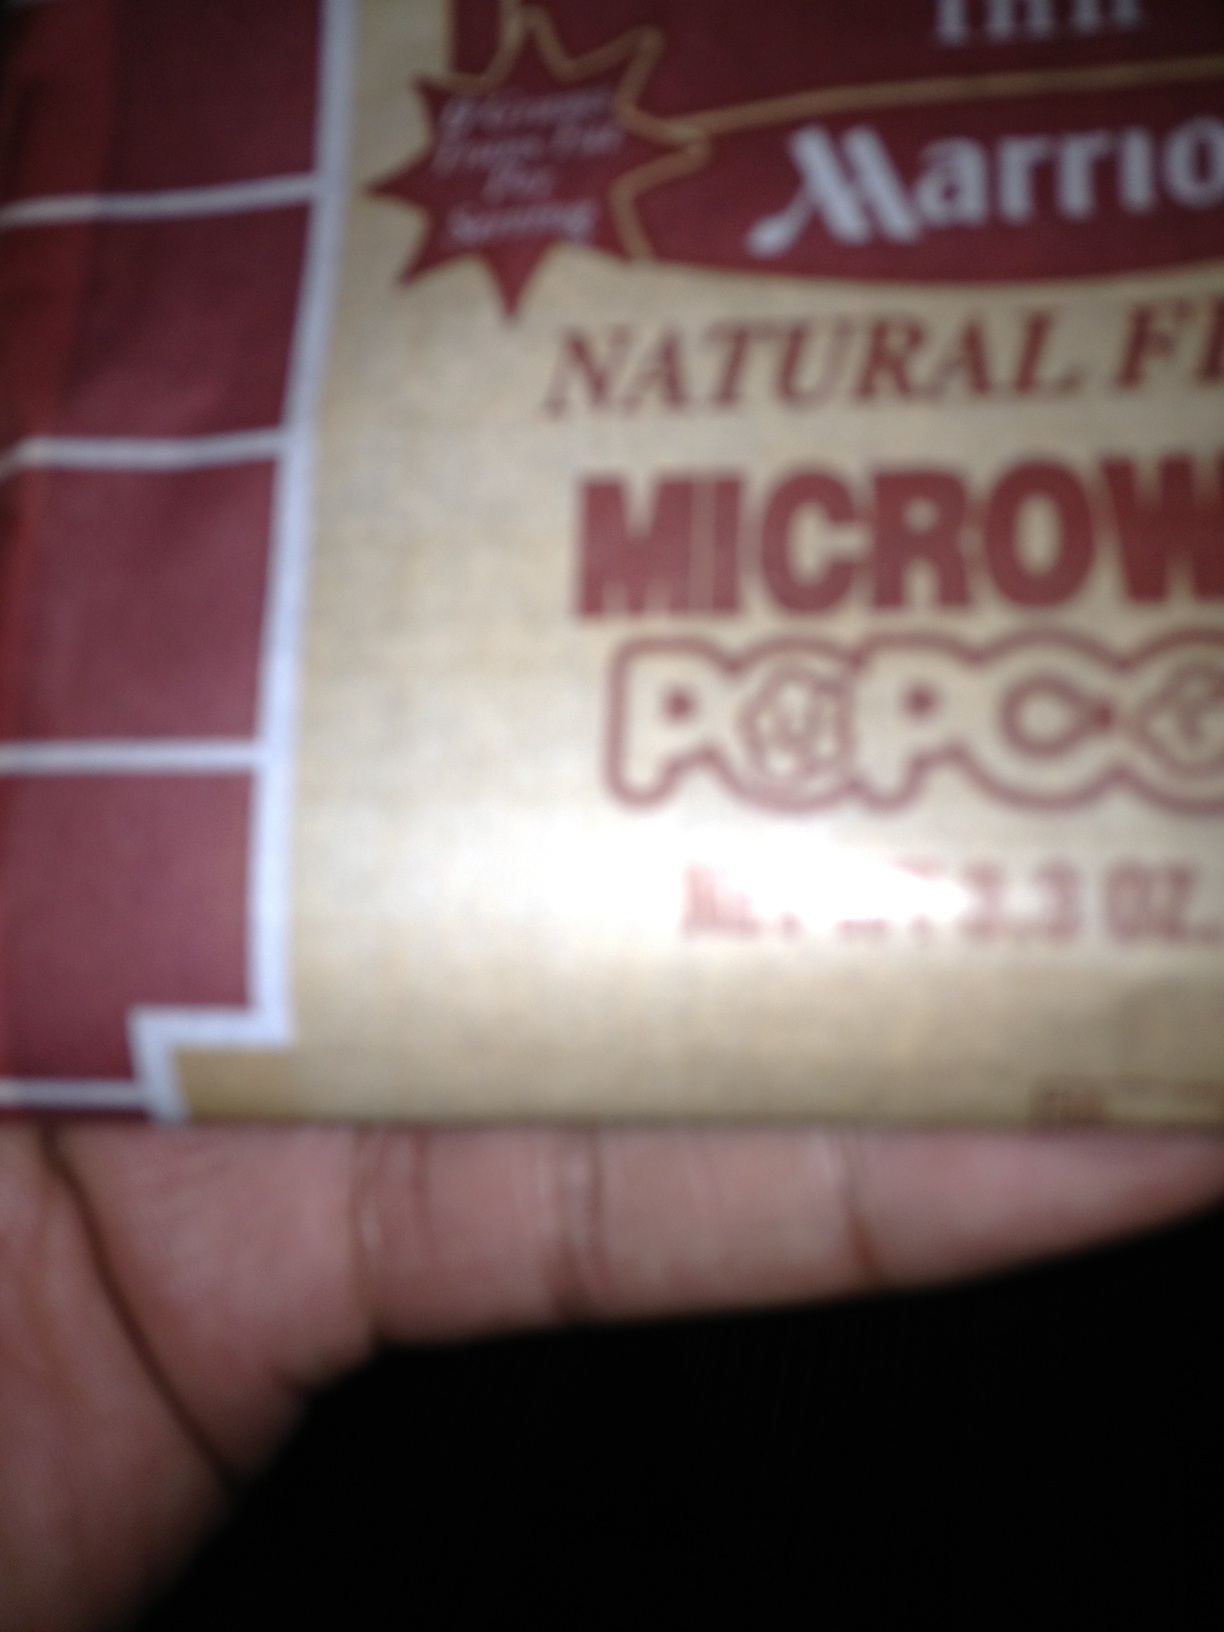What kind of popcorn is this? The popcorn is a 'Marriott Natural' brand, specifically microwavable popcorn. While the image doesn't provide details about the flavor or specific type (e.g., buttered, plain, etc.), the packaging suggests it's a natural product. 